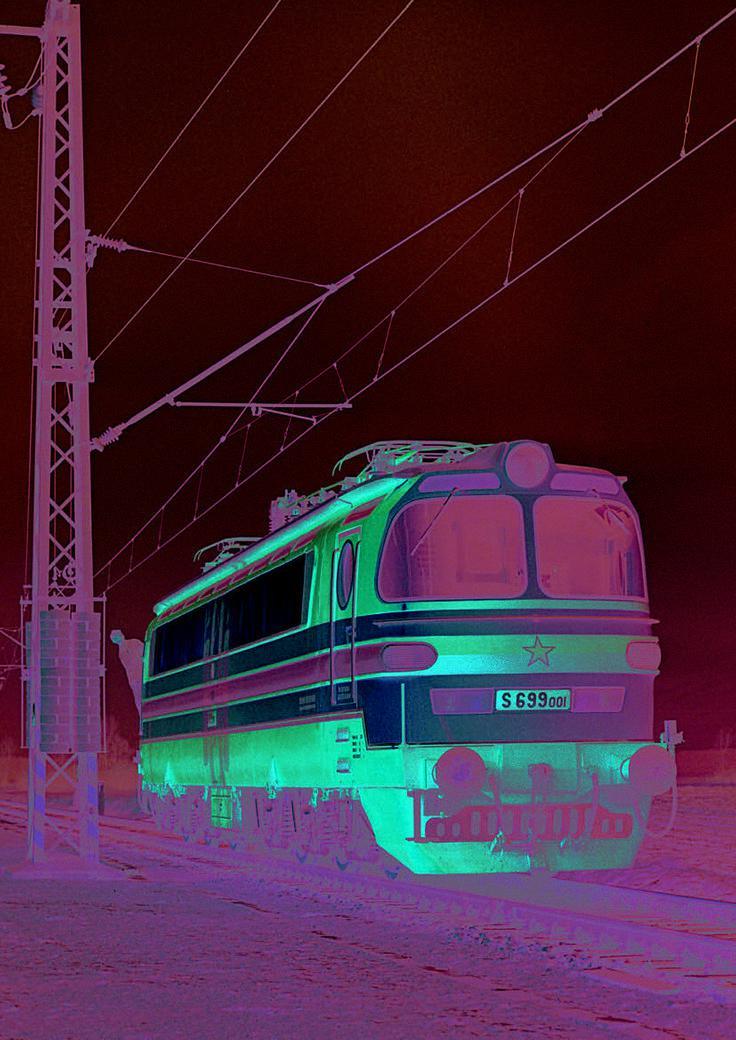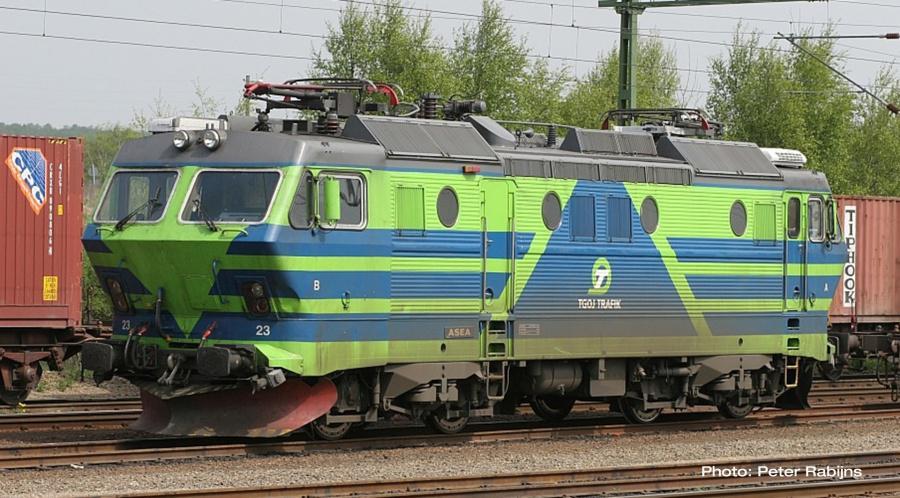The first image is the image on the left, the second image is the image on the right. Evaluate the accuracy of this statement regarding the images: "Both trains are primarily green and moving toward the right.". Is it true? Answer yes or no. No. The first image is the image on the left, the second image is the image on the right. Analyze the images presented: Is the assertion "All trains are greenish in color and heading rightward at an angle." valid? Answer yes or no. No. 